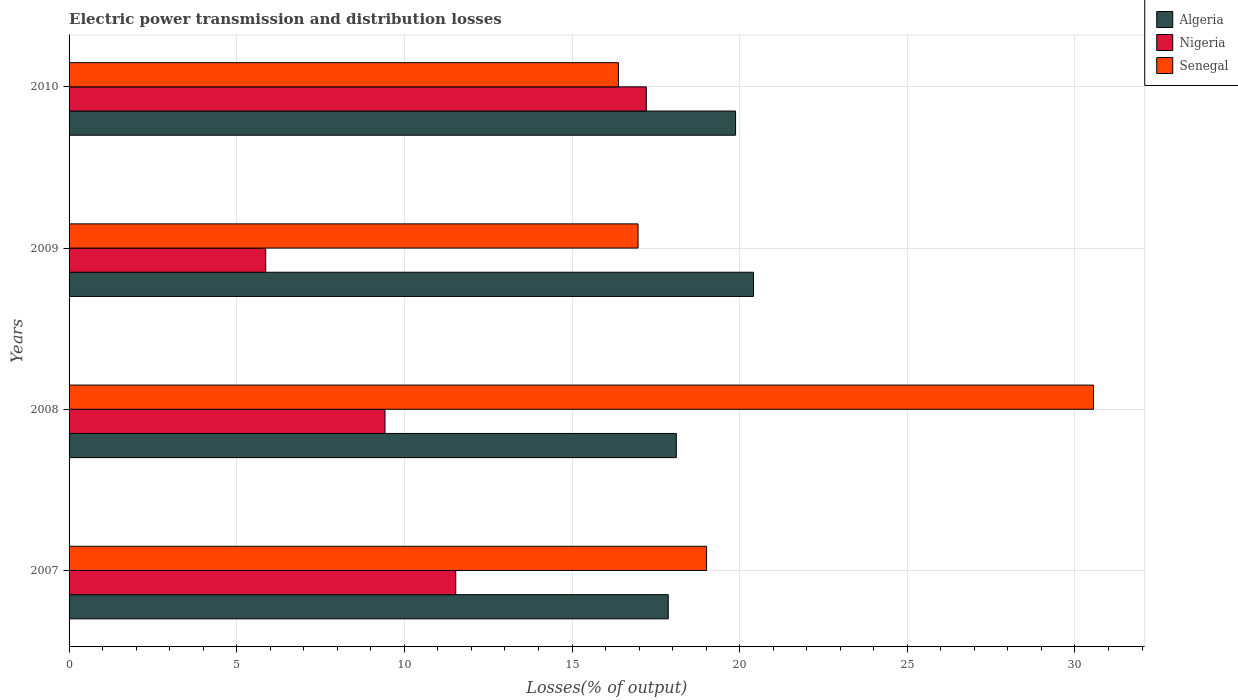How many different coloured bars are there?
Keep it short and to the point. 3. How many groups of bars are there?
Your response must be concise. 4. How many bars are there on the 1st tick from the top?
Your answer should be compact. 3. What is the label of the 3rd group of bars from the top?
Your response must be concise. 2008. What is the electric power transmission and distribution losses in Algeria in 2007?
Provide a succinct answer. 17.87. Across all years, what is the maximum electric power transmission and distribution losses in Nigeria?
Your response must be concise. 17.22. Across all years, what is the minimum electric power transmission and distribution losses in Nigeria?
Give a very brief answer. 5.87. In which year was the electric power transmission and distribution losses in Algeria maximum?
Provide a short and direct response. 2009. In which year was the electric power transmission and distribution losses in Nigeria minimum?
Offer a very short reply. 2009. What is the total electric power transmission and distribution losses in Algeria in the graph?
Keep it short and to the point. 76.27. What is the difference between the electric power transmission and distribution losses in Algeria in 2007 and that in 2009?
Your response must be concise. -2.54. What is the difference between the electric power transmission and distribution losses in Senegal in 2009 and the electric power transmission and distribution losses in Algeria in 2008?
Make the answer very short. -1.14. What is the average electric power transmission and distribution losses in Algeria per year?
Provide a short and direct response. 19.07. In the year 2010, what is the difference between the electric power transmission and distribution losses in Algeria and electric power transmission and distribution losses in Senegal?
Offer a terse response. 3.49. What is the ratio of the electric power transmission and distribution losses in Senegal in 2007 to that in 2010?
Your answer should be very brief. 1.16. What is the difference between the highest and the second highest electric power transmission and distribution losses in Nigeria?
Provide a short and direct response. 5.68. What is the difference between the highest and the lowest electric power transmission and distribution losses in Algeria?
Your answer should be very brief. 2.54. What does the 2nd bar from the top in 2007 represents?
Keep it short and to the point. Nigeria. What does the 3rd bar from the bottom in 2007 represents?
Offer a very short reply. Senegal. Is it the case that in every year, the sum of the electric power transmission and distribution losses in Senegal and electric power transmission and distribution losses in Nigeria is greater than the electric power transmission and distribution losses in Algeria?
Make the answer very short. Yes. How many bars are there?
Your response must be concise. 12. Are all the bars in the graph horizontal?
Offer a terse response. Yes. What is the difference between two consecutive major ticks on the X-axis?
Make the answer very short. 5. Are the values on the major ticks of X-axis written in scientific E-notation?
Offer a very short reply. No. Does the graph contain any zero values?
Offer a very short reply. No. How many legend labels are there?
Give a very brief answer. 3. How are the legend labels stacked?
Your answer should be very brief. Vertical. What is the title of the graph?
Keep it short and to the point. Electric power transmission and distribution losses. Does "Argentina" appear as one of the legend labels in the graph?
Your response must be concise. No. What is the label or title of the X-axis?
Ensure brevity in your answer.  Losses(% of output). What is the Losses(% of output) in Algeria in 2007?
Offer a very short reply. 17.87. What is the Losses(% of output) in Nigeria in 2007?
Make the answer very short. 11.53. What is the Losses(% of output) in Senegal in 2007?
Ensure brevity in your answer.  19.01. What is the Losses(% of output) in Algeria in 2008?
Your response must be concise. 18.11. What is the Losses(% of output) in Nigeria in 2008?
Offer a very short reply. 9.42. What is the Losses(% of output) of Senegal in 2008?
Offer a terse response. 30.55. What is the Losses(% of output) of Algeria in 2009?
Make the answer very short. 20.41. What is the Losses(% of output) of Nigeria in 2009?
Provide a short and direct response. 5.87. What is the Losses(% of output) of Senegal in 2009?
Offer a very short reply. 16.97. What is the Losses(% of output) in Algeria in 2010?
Offer a very short reply. 19.88. What is the Losses(% of output) in Nigeria in 2010?
Offer a very short reply. 17.22. What is the Losses(% of output) in Senegal in 2010?
Provide a succinct answer. 16.38. Across all years, what is the maximum Losses(% of output) in Algeria?
Ensure brevity in your answer.  20.41. Across all years, what is the maximum Losses(% of output) of Nigeria?
Ensure brevity in your answer.  17.22. Across all years, what is the maximum Losses(% of output) of Senegal?
Your answer should be very brief. 30.55. Across all years, what is the minimum Losses(% of output) in Algeria?
Provide a succinct answer. 17.87. Across all years, what is the minimum Losses(% of output) in Nigeria?
Provide a succinct answer. 5.87. Across all years, what is the minimum Losses(% of output) in Senegal?
Offer a terse response. 16.38. What is the total Losses(% of output) of Algeria in the graph?
Ensure brevity in your answer.  76.27. What is the total Losses(% of output) of Nigeria in the graph?
Your response must be concise. 44.04. What is the total Losses(% of output) of Senegal in the graph?
Your answer should be compact. 82.92. What is the difference between the Losses(% of output) in Algeria in 2007 and that in 2008?
Your answer should be compact. -0.24. What is the difference between the Losses(% of output) in Nigeria in 2007 and that in 2008?
Keep it short and to the point. 2.11. What is the difference between the Losses(% of output) in Senegal in 2007 and that in 2008?
Offer a very short reply. -11.54. What is the difference between the Losses(% of output) of Algeria in 2007 and that in 2009?
Ensure brevity in your answer.  -2.54. What is the difference between the Losses(% of output) in Nigeria in 2007 and that in 2009?
Keep it short and to the point. 5.67. What is the difference between the Losses(% of output) in Senegal in 2007 and that in 2009?
Offer a very short reply. 2.04. What is the difference between the Losses(% of output) in Algeria in 2007 and that in 2010?
Your answer should be very brief. -2.01. What is the difference between the Losses(% of output) in Nigeria in 2007 and that in 2010?
Your answer should be compact. -5.68. What is the difference between the Losses(% of output) in Senegal in 2007 and that in 2010?
Your answer should be compact. 2.63. What is the difference between the Losses(% of output) in Algeria in 2008 and that in 2009?
Ensure brevity in your answer.  -2.3. What is the difference between the Losses(% of output) in Nigeria in 2008 and that in 2009?
Offer a very short reply. 3.56. What is the difference between the Losses(% of output) of Senegal in 2008 and that in 2009?
Keep it short and to the point. 13.58. What is the difference between the Losses(% of output) in Algeria in 2008 and that in 2010?
Offer a terse response. -1.77. What is the difference between the Losses(% of output) of Nigeria in 2008 and that in 2010?
Your answer should be very brief. -7.79. What is the difference between the Losses(% of output) in Senegal in 2008 and that in 2010?
Make the answer very short. 14.17. What is the difference between the Losses(% of output) of Algeria in 2009 and that in 2010?
Ensure brevity in your answer.  0.53. What is the difference between the Losses(% of output) of Nigeria in 2009 and that in 2010?
Keep it short and to the point. -11.35. What is the difference between the Losses(% of output) in Senegal in 2009 and that in 2010?
Make the answer very short. 0.58. What is the difference between the Losses(% of output) in Algeria in 2007 and the Losses(% of output) in Nigeria in 2008?
Offer a terse response. 8.45. What is the difference between the Losses(% of output) of Algeria in 2007 and the Losses(% of output) of Senegal in 2008?
Offer a terse response. -12.68. What is the difference between the Losses(% of output) of Nigeria in 2007 and the Losses(% of output) of Senegal in 2008?
Keep it short and to the point. -19.02. What is the difference between the Losses(% of output) of Algeria in 2007 and the Losses(% of output) of Nigeria in 2009?
Offer a terse response. 12. What is the difference between the Losses(% of output) of Algeria in 2007 and the Losses(% of output) of Senegal in 2009?
Give a very brief answer. 0.9. What is the difference between the Losses(% of output) of Nigeria in 2007 and the Losses(% of output) of Senegal in 2009?
Keep it short and to the point. -5.44. What is the difference between the Losses(% of output) of Algeria in 2007 and the Losses(% of output) of Nigeria in 2010?
Your answer should be compact. 0.65. What is the difference between the Losses(% of output) of Algeria in 2007 and the Losses(% of output) of Senegal in 2010?
Offer a terse response. 1.49. What is the difference between the Losses(% of output) of Nigeria in 2007 and the Losses(% of output) of Senegal in 2010?
Your answer should be very brief. -4.85. What is the difference between the Losses(% of output) in Algeria in 2008 and the Losses(% of output) in Nigeria in 2009?
Offer a terse response. 12.25. What is the difference between the Losses(% of output) in Algeria in 2008 and the Losses(% of output) in Senegal in 2009?
Keep it short and to the point. 1.14. What is the difference between the Losses(% of output) of Nigeria in 2008 and the Losses(% of output) of Senegal in 2009?
Give a very brief answer. -7.55. What is the difference between the Losses(% of output) in Algeria in 2008 and the Losses(% of output) in Nigeria in 2010?
Provide a short and direct response. 0.89. What is the difference between the Losses(% of output) of Algeria in 2008 and the Losses(% of output) of Senegal in 2010?
Your answer should be compact. 1.73. What is the difference between the Losses(% of output) of Nigeria in 2008 and the Losses(% of output) of Senegal in 2010?
Provide a short and direct response. -6.96. What is the difference between the Losses(% of output) of Algeria in 2009 and the Losses(% of output) of Nigeria in 2010?
Provide a succinct answer. 3.2. What is the difference between the Losses(% of output) of Algeria in 2009 and the Losses(% of output) of Senegal in 2010?
Your response must be concise. 4.03. What is the difference between the Losses(% of output) in Nigeria in 2009 and the Losses(% of output) in Senegal in 2010?
Your response must be concise. -10.52. What is the average Losses(% of output) in Algeria per year?
Your answer should be compact. 19.07. What is the average Losses(% of output) in Nigeria per year?
Your answer should be compact. 11.01. What is the average Losses(% of output) in Senegal per year?
Keep it short and to the point. 20.73. In the year 2007, what is the difference between the Losses(% of output) of Algeria and Losses(% of output) of Nigeria?
Ensure brevity in your answer.  6.34. In the year 2007, what is the difference between the Losses(% of output) in Algeria and Losses(% of output) in Senegal?
Give a very brief answer. -1.14. In the year 2007, what is the difference between the Losses(% of output) of Nigeria and Losses(% of output) of Senegal?
Ensure brevity in your answer.  -7.48. In the year 2008, what is the difference between the Losses(% of output) of Algeria and Losses(% of output) of Nigeria?
Provide a succinct answer. 8.69. In the year 2008, what is the difference between the Losses(% of output) of Algeria and Losses(% of output) of Senegal?
Ensure brevity in your answer.  -12.44. In the year 2008, what is the difference between the Losses(% of output) in Nigeria and Losses(% of output) in Senegal?
Keep it short and to the point. -21.13. In the year 2009, what is the difference between the Losses(% of output) of Algeria and Losses(% of output) of Nigeria?
Give a very brief answer. 14.55. In the year 2009, what is the difference between the Losses(% of output) of Algeria and Losses(% of output) of Senegal?
Give a very brief answer. 3.44. In the year 2009, what is the difference between the Losses(% of output) in Nigeria and Losses(% of output) in Senegal?
Your answer should be compact. -11.1. In the year 2010, what is the difference between the Losses(% of output) of Algeria and Losses(% of output) of Nigeria?
Provide a short and direct response. 2.66. In the year 2010, what is the difference between the Losses(% of output) of Algeria and Losses(% of output) of Senegal?
Your response must be concise. 3.49. In the year 2010, what is the difference between the Losses(% of output) of Nigeria and Losses(% of output) of Senegal?
Your answer should be very brief. 0.83. What is the ratio of the Losses(% of output) of Algeria in 2007 to that in 2008?
Provide a succinct answer. 0.99. What is the ratio of the Losses(% of output) in Nigeria in 2007 to that in 2008?
Ensure brevity in your answer.  1.22. What is the ratio of the Losses(% of output) in Senegal in 2007 to that in 2008?
Offer a terse response. 0.62. What is the ratio of the Losses(% of output) in Algeria in 2007 to that in 2009?
Make the answer very short. 0.88. What is the ratio of the Losses(% of output) of Nigeria in 2007 to that in 2009?
Ensure brevity in your answer.  1.97. What is the ratio of the Losses(% of output) of Senegal in 2007 to that in 2009?
Your answer should be compact. 1.12. What is the ratio of the Losses(% of output) in Algeria in 2007 to that in 2010?
Give a very brief answer. 0.9. What is the ratio of the Losses(% of output) of Nigeria in 2007 to that in 2010?
Provide a short and direct response. 0.67. What is the ratio of the Losses(% of output) of Senegal in 2007 to that in 2010?
Keep it short and to the point. 1.16. What is the ratio of the Losses(% of output) in Algeria in 2008 to that in 2009?
Give a very brief answer. 0.89. What is the ratio of the Losses(% of output) in Nigeria in 2008 to that in 2009?
Give a very brief answer. 1.61. What is the ratio of the Losses(% of output) in Senegal in 2008 to that in 2009?
Offer a very short reply. 1.8. What is the ratio of the Losses(% of output) in Algeria in 2008 to that in 2010?
Offer a very short reply. 0.91. What is the ratio of the Losses(% of output) in Nigeria in 2008 to that in 2010?
Your answer should be very brief. 0.55. What is the ratio of the Losses(% of output) in Senegal in 2008 to that in 2010?
Offer a very short reply. 1.86. What is the ratio of the Losses(% of output) of Algeria in 2009 to that in 2010?
Your response must be concise. 1.03. What is the ratio of the Losses(% of output) in Nigeria in 2009 to that in 2010?
Give a very brief answer. 0.34. What is the ratio of the Losses(% of output) in Senegal in 2009 to that in 2010?
Your answer should be very brief. 1.04. What is the difference between the highest and the second highest Losses(% of output) in Algeria?
Offer a terse response. 0.53. What is the difference between the highest and the second highest Losses(% of output) in Nigeria?
Ensure brevity in your answer.  5.68. What is the difference between the highest and the second highest Losses(% of output) in Senegal?
Offer a very short reply. 11.54. What is the difference between the highest and the lowest Losses(% of output) of Algeria?
Ensure brevity in your answer.  2.54. What is the difference between the highest and the lowest Losses(% of output) of Nigeria?
Keep it short and to the point. 11.35. What is the difference between the highest and the lowest Losses(% of output) in Senegal?
Make the answer very short. 14.17. 